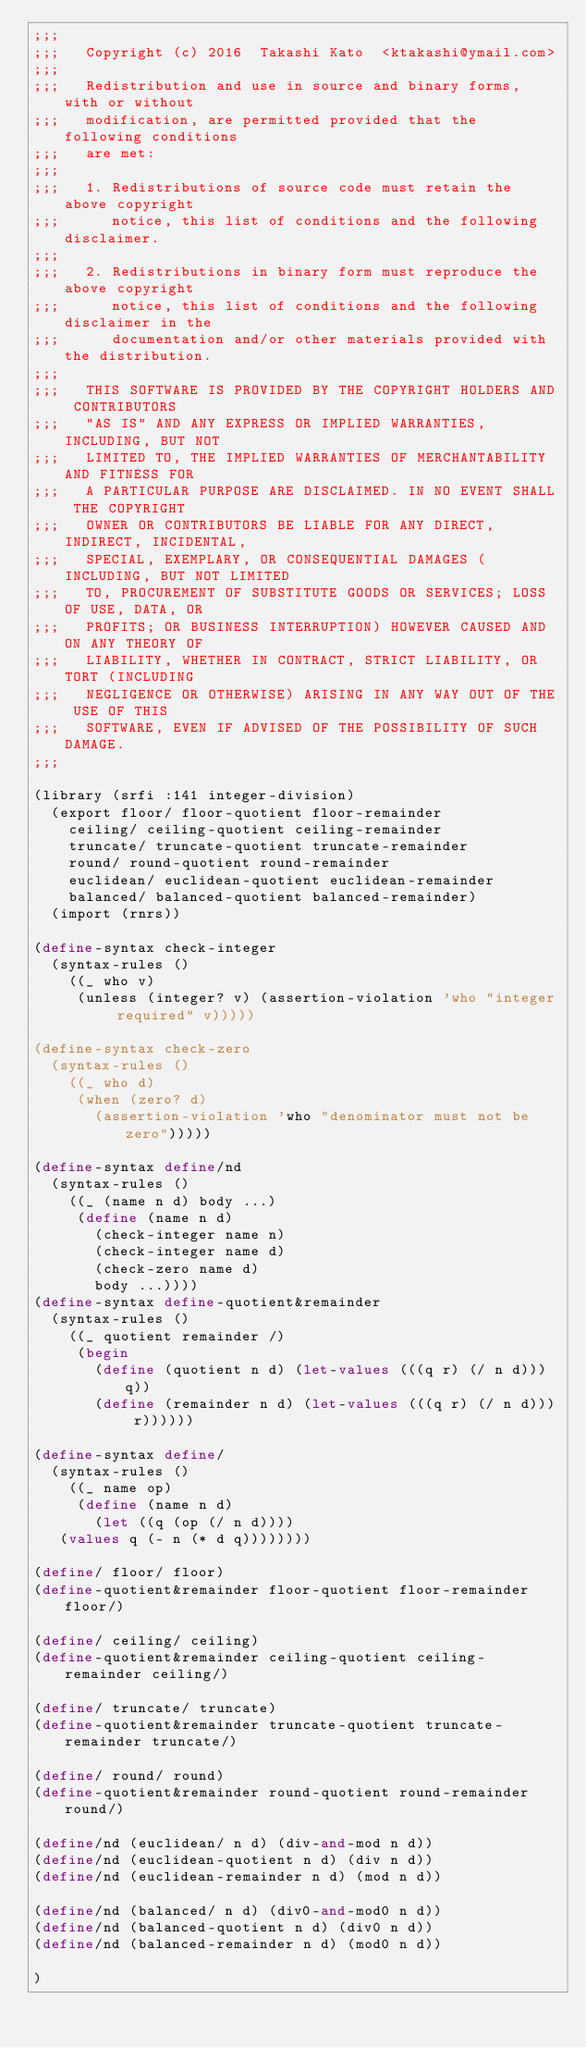<code> <loc_0><loc_0><loc_500><loc_500><_Scheme_>;;;
;;;   Copyright (c) 2016  Takashi Kato  <ktakashi@ymail.com>
;;;
;;;   Redistribution and use in source and binary forms, with or without
;;;   modification, are permitted provided that the following conditions
;;;   are met:
;;;
;;;   1. Redistributions of source code must retain the above copyright
;;;      notice, this list of conditions and the following disclaimer.
;;;
;;;   2. Redistributions in binary form must reproduce the above copyright
;;;      notice, this list of conditions and the following disclaimer in the
;;;      documentation and/or other materials provided with the distribution.
;;;
;;;   THIS SOFTWARE IS PROVIDED BY THE COPYRIGHT HOLDERS AND CONTRIBUTORS
;;;   "AS IS" AND ANY EXPRESS OR IMPLIED WARRANTIES, INCLUDING, BUT NOT
;;;   LIMITED TO, THE IMPLIED WARRANTIES OF MERCHANTABILITY AND FITNESS FOR
;;;   A PARTICULAR PURPOSE ARE DISCLAIMED. IN NO EVENT SHALL THE COPYRIGHT
;;;   OWNER OR CONTRIBUTORS BE LIABLE FOR ANY DIRECT, INDIRECT, INCIDENTAL,
;;;   SPECIAL, EXEMPLARY, OR CONSEQUENTIAL DAMAGES (INCLUDING, BUT NOT LIMITED
;;;   TO, PROCUREMENT OF SUBSTITUTE GOODS OR SERVICES; LOSS OF USE, DATA, OR
;;;   PROFITS; OR BUSINESS INTERRUPTION) HOWEVER CAUSED AND ON ANY THEORY OF
;;;   LIABILITY, WHETHER IN CONTRACT, STRICT LIABILITY, OR TORT (INCLUDING
;;;   NEGLIGENCE OR OTHERWISE) ARISING IN ANY WAY OUT OF THE USE OF THIS
;;;   SOFTWARE, EVEN IF ADVISED OF THE POSSIBILITY OF SUCH DAMAGE.
;;;

(library (srfi :141 integer-division)
  (export floor/ floor-quotient floor-remainder
	  ceiling/ ceiling-quotient ceiling-remainder
	  truncate/ truncate-quotient truncate-remainder
	  round/ round-quotient round-remainder
	  euclidean/ euclidean-quotient euclidean-remainder
	  balanced/ balanced-quotient balanced-remainder)
  (import (rnrs))

(define-syntax check-integer
  (syntax-rules ()
    ((_ who v)
     (unless (integer? v) (assertion-violation 'who "integer required" v)))))

(define-syntax check-zero
  (syntax-rules ()
    ((_ who d)
     (when (zero? d)
       (assertion-violation 'who "denominator must not be zero")))))

(define-syntax define/nd
  (syntax-rules ()
    ((_ (name n d) body ...)
     (define (name n d)
       (check-integer name n)
       (check-integer name d)
       (check-zero name d)
       body ...))))
(define-syntax define-quotient&remainder
  (syntax-rules ()
    ((_ quotient remainder /)
     (begin
       (define (quotient n d) (let-values (((q r) (/ n d))) q))
       (define (remainder n d) (let-values (((q r) (/ n d))) r))))))
       
(define-syntax define/
  (syntax-rules ()
    ((_ name op)
     (define (name n d)
       (let ((q (op (/ n d))))
	 (values q (- n (* d q))))))))

(define/ floor/ floor)
(define-quotient&remainder floor-quotient floor-remainder floor/)

(define/ ceiling/ ceiling)
(define-quotient&remainder ceiling-quotient ceiling-remainder ceiling/)

(define/ truncate/ truncate)
(define-quotient&remainder truncate-quotient truncate-remainder truncate/)

(define/ round/ round)
(define-quotient&remainder round-quotient round-remainder round/)

(define/nd (euclidean/ n d) (div-and-mod n d))
(define/nd (euclidean-quotient n d) (div n d))
(define/nd (euclidean-remainder n d) (mod n d))

(define/nd (balanced/ n d) (div0-and-mod0 n d))
(define/nd (balanced-quotient n d) (div0 n d))
(define/nd (balanced-remainder n d) (mod0 n d))

)
	  
</code> 